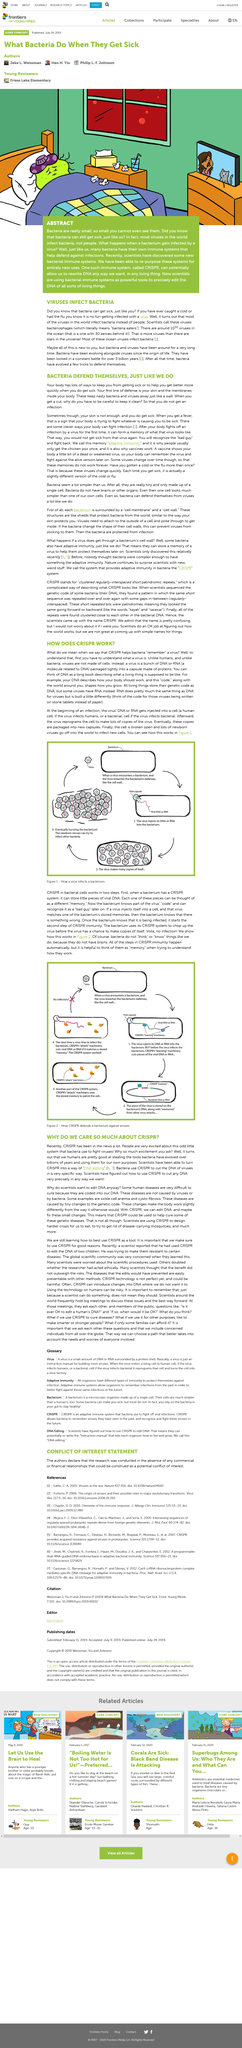Specify some key components in this picture. Bacteria possess a defense mechanism that is analogous to the human immune system, where the skin serves as a barrier to prevent the entry of harmful pathogens. Your body's immune system has a clever strategy for fighting off infections. When it encounters a virus for the first time, it creates a memory of the virus's appearance, which helps it recognize and defeat the virus before it causes illness again. I declare that viruses are not made of cells. The virus DNA or RNA is injected into a cell. The steps 2, 3, and 4 in the image shown are performed automatically or stored in memory, except for the CRISPR steps, which occur automatically. 